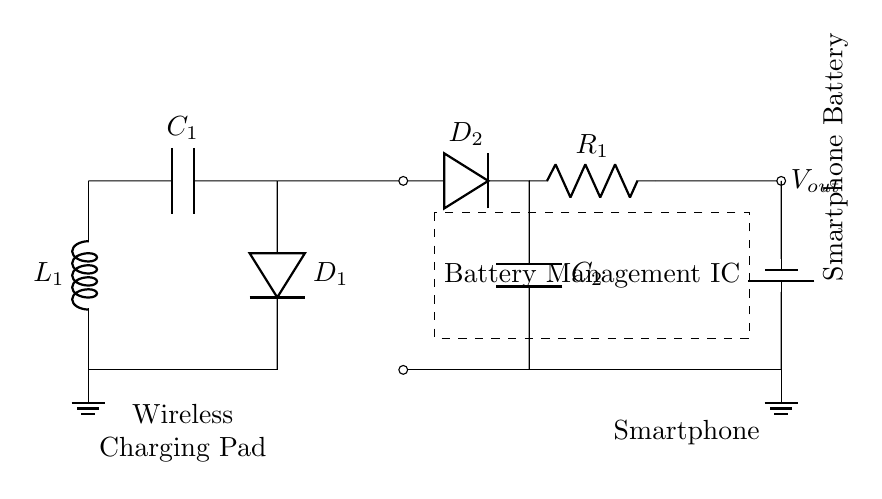What is the output voltage of the circuit? The output voltage is indicated as V_out in the circuit. It is typically the voltage delivered to charge the smartphone battery, which commonly is around 5 volts.
Answer: V_out What component regulates the voltage? The component that regulates the voltage in the circuit is labeled R_1. It acts as a resistor to control the voltage supplied to the load.
Answer: R_1 What is the frequency role of the component labeled L_1? L_1 serves as the inductance in the wireless charging circuit, which forms part of the resonant circuit, allowing it to operate at a certain frequency suitable for wireless energy transfer.
Answer: Inductance How many diodes are present in the circuit? There are two diodes present in the circuit, D_1 and D_2, which are used for rectifying the AC signal to DC for charging the smartphone.
Answer: Two What is the purpose of the component labeled C_1? The component labeled C_1 acts as a capacitor that helps in filtering and smoothing the output voltage to reduce fluctuations, enhancing the quality of the power supplied to the smartphone.
Answer: Filtering capacitor Which component is responsible for managing the smartphone battery? The component responsible for managing the smartphone battery is the Battery Management IC, which ensures safe charging and discharging of the battery.
Answer: Battery Management IC 